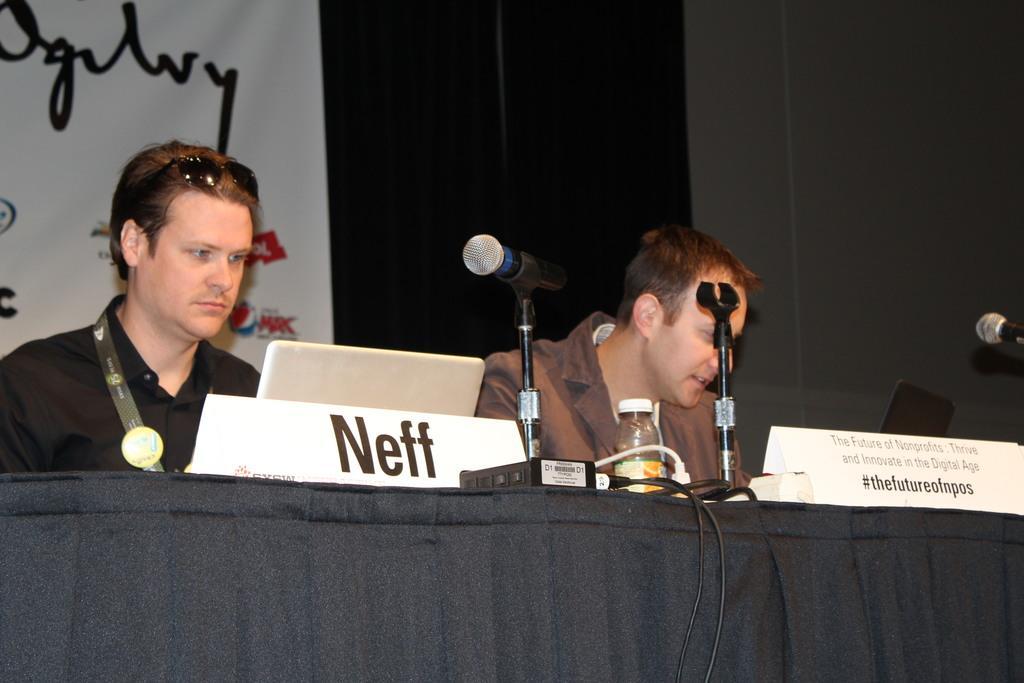Describe this image in one or two sentences. There are two persons present in the middle of this image. The person on the left side is wearing a black color shirt. There is a laptop, Mice and other objects are kept on a table which is covered with a black color cloth. There is a wall in the background. We can see a wall poster present on the left side of this image. 